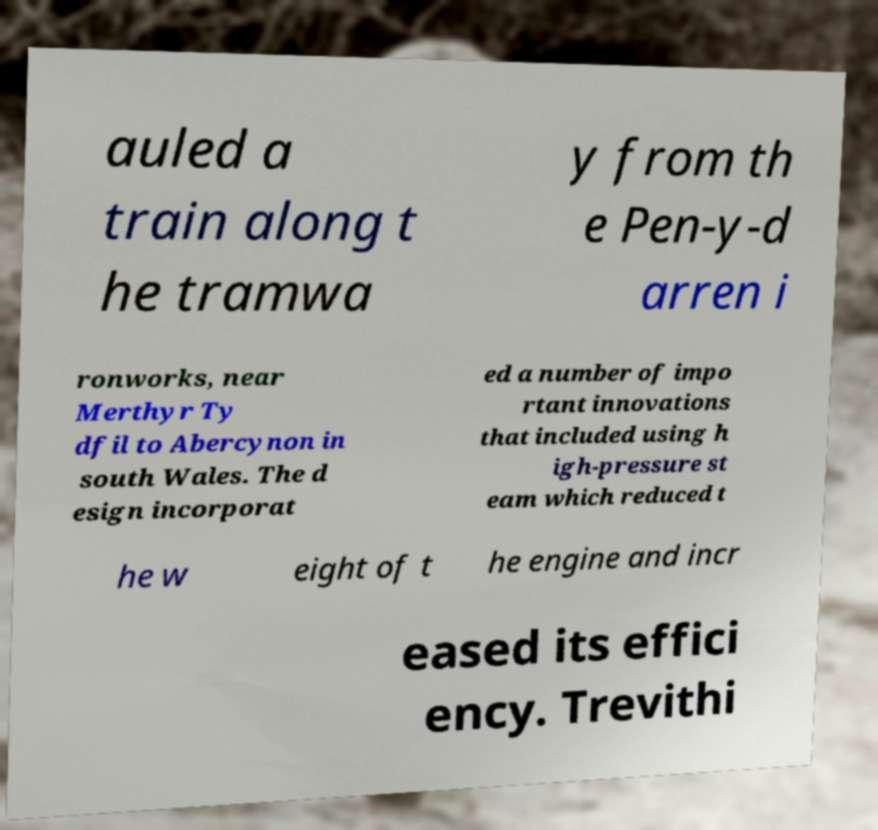I need the written content from this picture converted into text. Can you do that? auled a train along t he tramwa y from th e Pen-y-d arren i ronworks, near Merthyr Ty dfil to Abercynon in south Wales. The d esign incorporat ed a number of impo rtant innovations that included using h igh-pressure st eam which reduced t he w eight of t he engine and incr eased its effici ency. Trevithi 